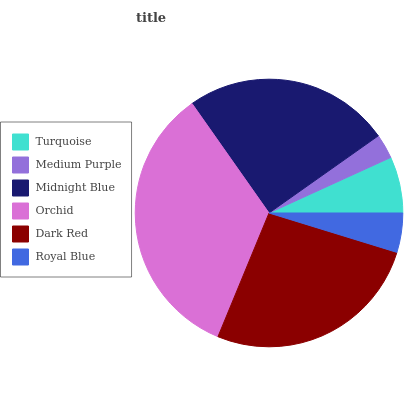Is Medium Purple the minimum?
Answer yes or no. Yes. Is Orchid the maximum?
Answer yes or no. Yes. Is Midnight Blue the minimum?
Answer yes or no. No. Is Midnight Blue the maximum?
Answer yes or no. No. Is Midnight Blue greater than Medium Purple?
Answer yes or no. Yes. Is Medium Purple less than Midnight Blue?
Answer yes or no. Yes. Is Medium Purple greater than Midnight Blue?
Answer yes or no. No. Is Midnight Blue less than Medium Purple?
Answer yes or no. No. Is Midnight Blue the high median?
Answer yes or no. Yes. Is Turquoise the low median?
Answer yes or no. Yes. Is Dark Red the high median?
Answer yes or no. No. Is Orchid the low median?
Answer yes or no. No. 